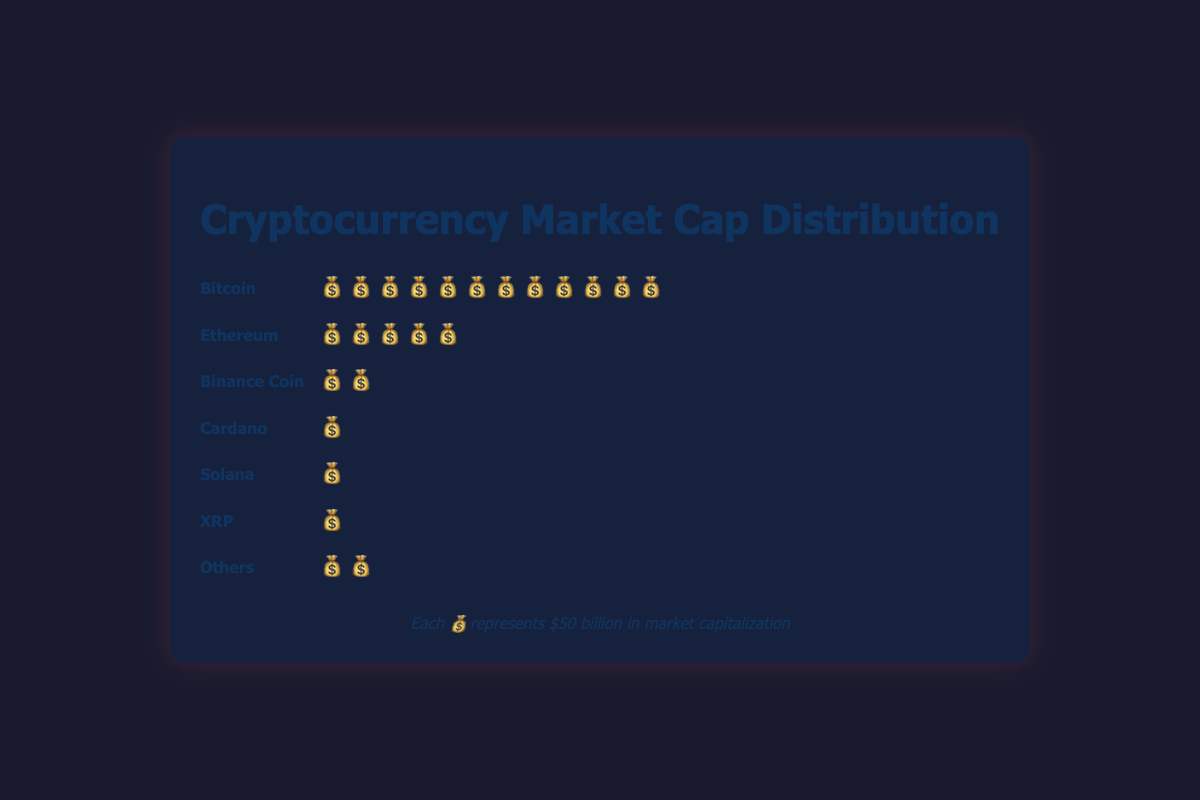What is the total market capitalization represented by Bitcoin in the figure? Bitcoin has 12 symbols, and each symbol represents $50 billion. So, the total market capitalization for Bitcoin is 12 * $50 billion = $600 billion.
Answer: $600 billion How many categories are displayed in the plot? There are specific categories listed in the plot: Bitcoin, Ethereum, Binance Coin, Cardano, Solana, XRP, and Others. Counting these categories gives us 7.
Answer: 7 Which cryptocurrency has the smallest market capitalization based on the figure? Each symbol represents $50 billion. Cardano, Solana, and XRP each have 1 symbol, and "Others" has 2 symbols. So, each of Cardano, Solana, and XRP has $50 billion, making them the smallest in terms of market capitalization.
Answer: Cardano, Solana, and XRP What is the total market capitalization for cryptocurrencies labeled as "Others"? "Others" has 2 symbols. Each symbol represents $50 billion. Therefore, 2 * $50 billion = $100 billion.
Answer: $100 billion How does the market capitalization of Ethereum compare to that of Binance Coin? Ethereum has 5 symbols and Binance Coin has 2 symbols. Each symbol represents $50 billion. Therefore, Ethereum has 5 * $50 billion = $250 billion, and Binance Coin has 2 * $50 billion = $100 billion, making Ethereum's market capitalization larger.
Answer: Ethereum's market cap is larger What's the combined market capitalization of Bitcoin and Ethereum? Bitcoin has 12 symbols, Ethereum has 5 symbols. Each represents $50 billion. Therefore, Bitcoin's total is 12 * $50 billion = $600 billion and Ethereum's is 5 * $50 billion = $250 billion. Combined, it's $600 billion + $250 billion = $850 billion.
Answer: $850 billion What is the percentage of the total market capitalization that Bitcoin represents? Total market capitalization for all cryptocurrencies is calculated by adding all the symbols: (12 + 5 + 2 + 1 + 1 + 1 + 2) * $50 billion. Total is 24 * $50 billion = $1200 billion. Bitcoin's percentage is (Bitcoin's cap ($600 billion) / Total cap ($1200 billion)) * 100% = 50%.
Answer: 50% Which category has double the market capitalization of Solana? Solana has 1 symbol representing $50 billion. Ethereum has 5 symbols representing $250 billion, Bitcoin has 12 symbols representing $600 billion, Binance Coin has 2 symbols representing $100 billion, which are all more than double of $50 billion.
Answer: Ethereum, Bitcoin, Binance Coin 